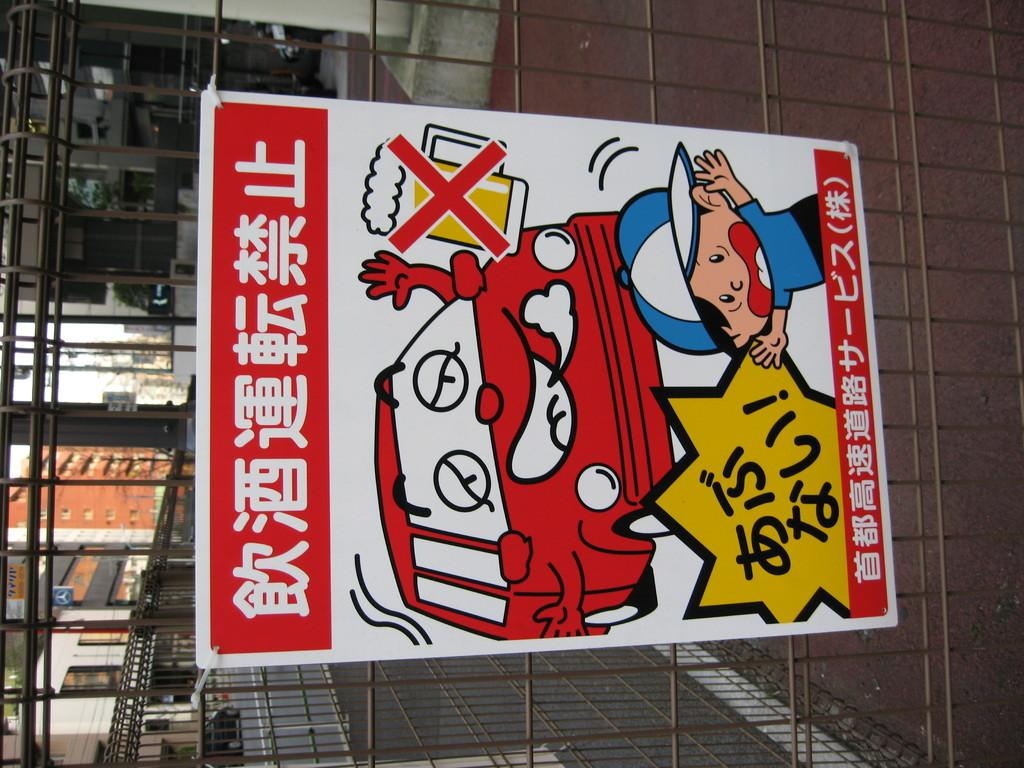What is the main object in the image? There is a board in the image. What is the purpose of the grille in the image? The grille allows for the visibility of buildings, a road, additional boards, and the sky. What can be seen through the grille? Buildings, a road, additional boards, and the sky are visible through the grille. How does the uncle laugh while looking through the grille in the image? There is no uncle or laughter present in the image. 